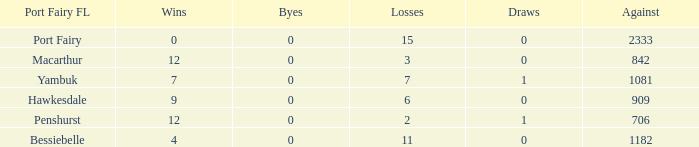How many victories does port fairy have that are greater than 2333? None. 